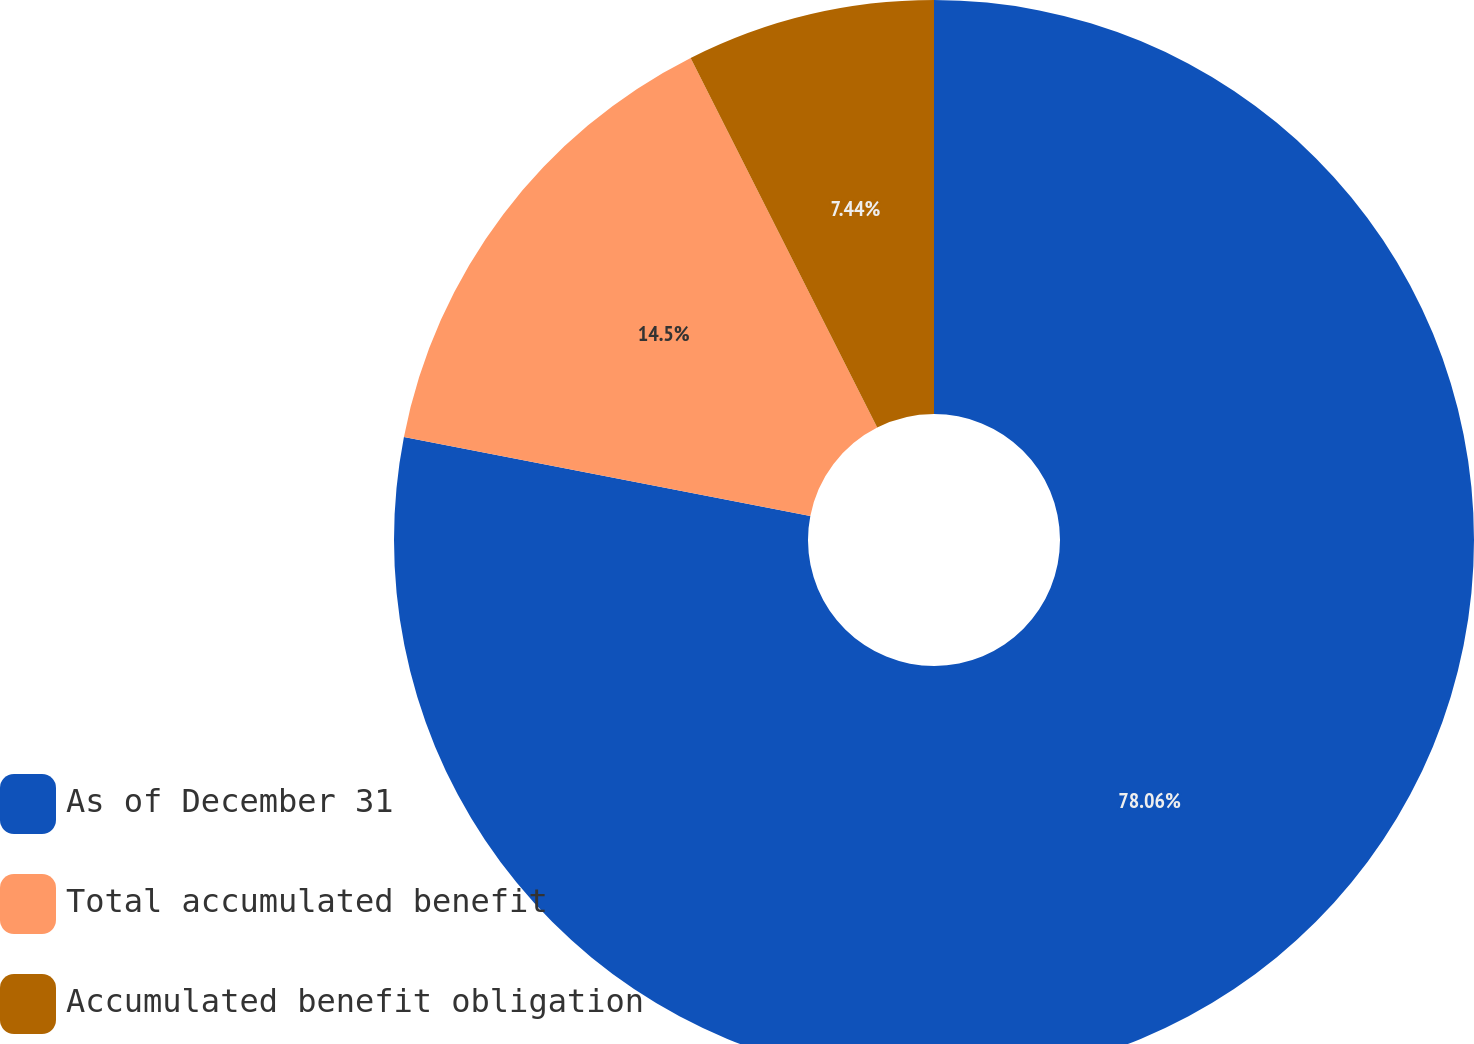Convert chart to OTSL. <chart><loc_0><loc_0><loc_500><loc_500><pie_chart><fcel>As of December 31<fcel>Total accumulated benefit<fcel>Accumulated benefit obligation<nl><fcel>78.05%<fcel>14.5%<fcel>7.44%<nl></chart> 